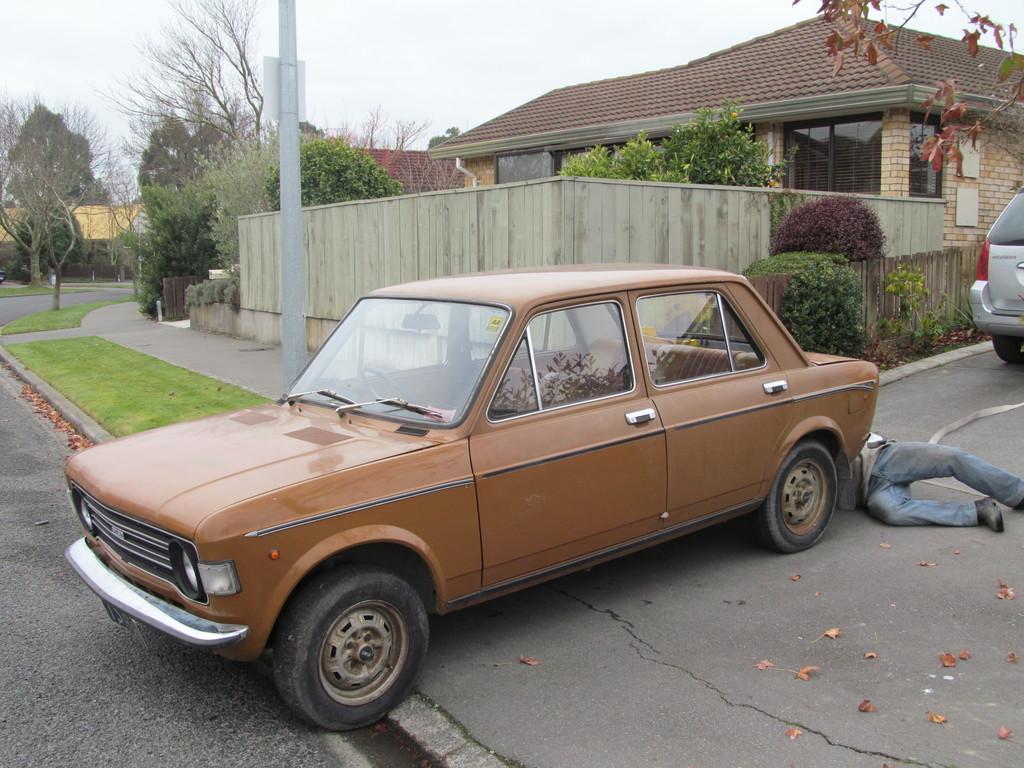Please provide a concise description of this image. In the foreground of the picture there are dry leaves, car, path, road and a man. In the center of the picture there are trees, plants, car, stem, pole, grass, dry leaves, wall and a house. Sky is cloudy. 